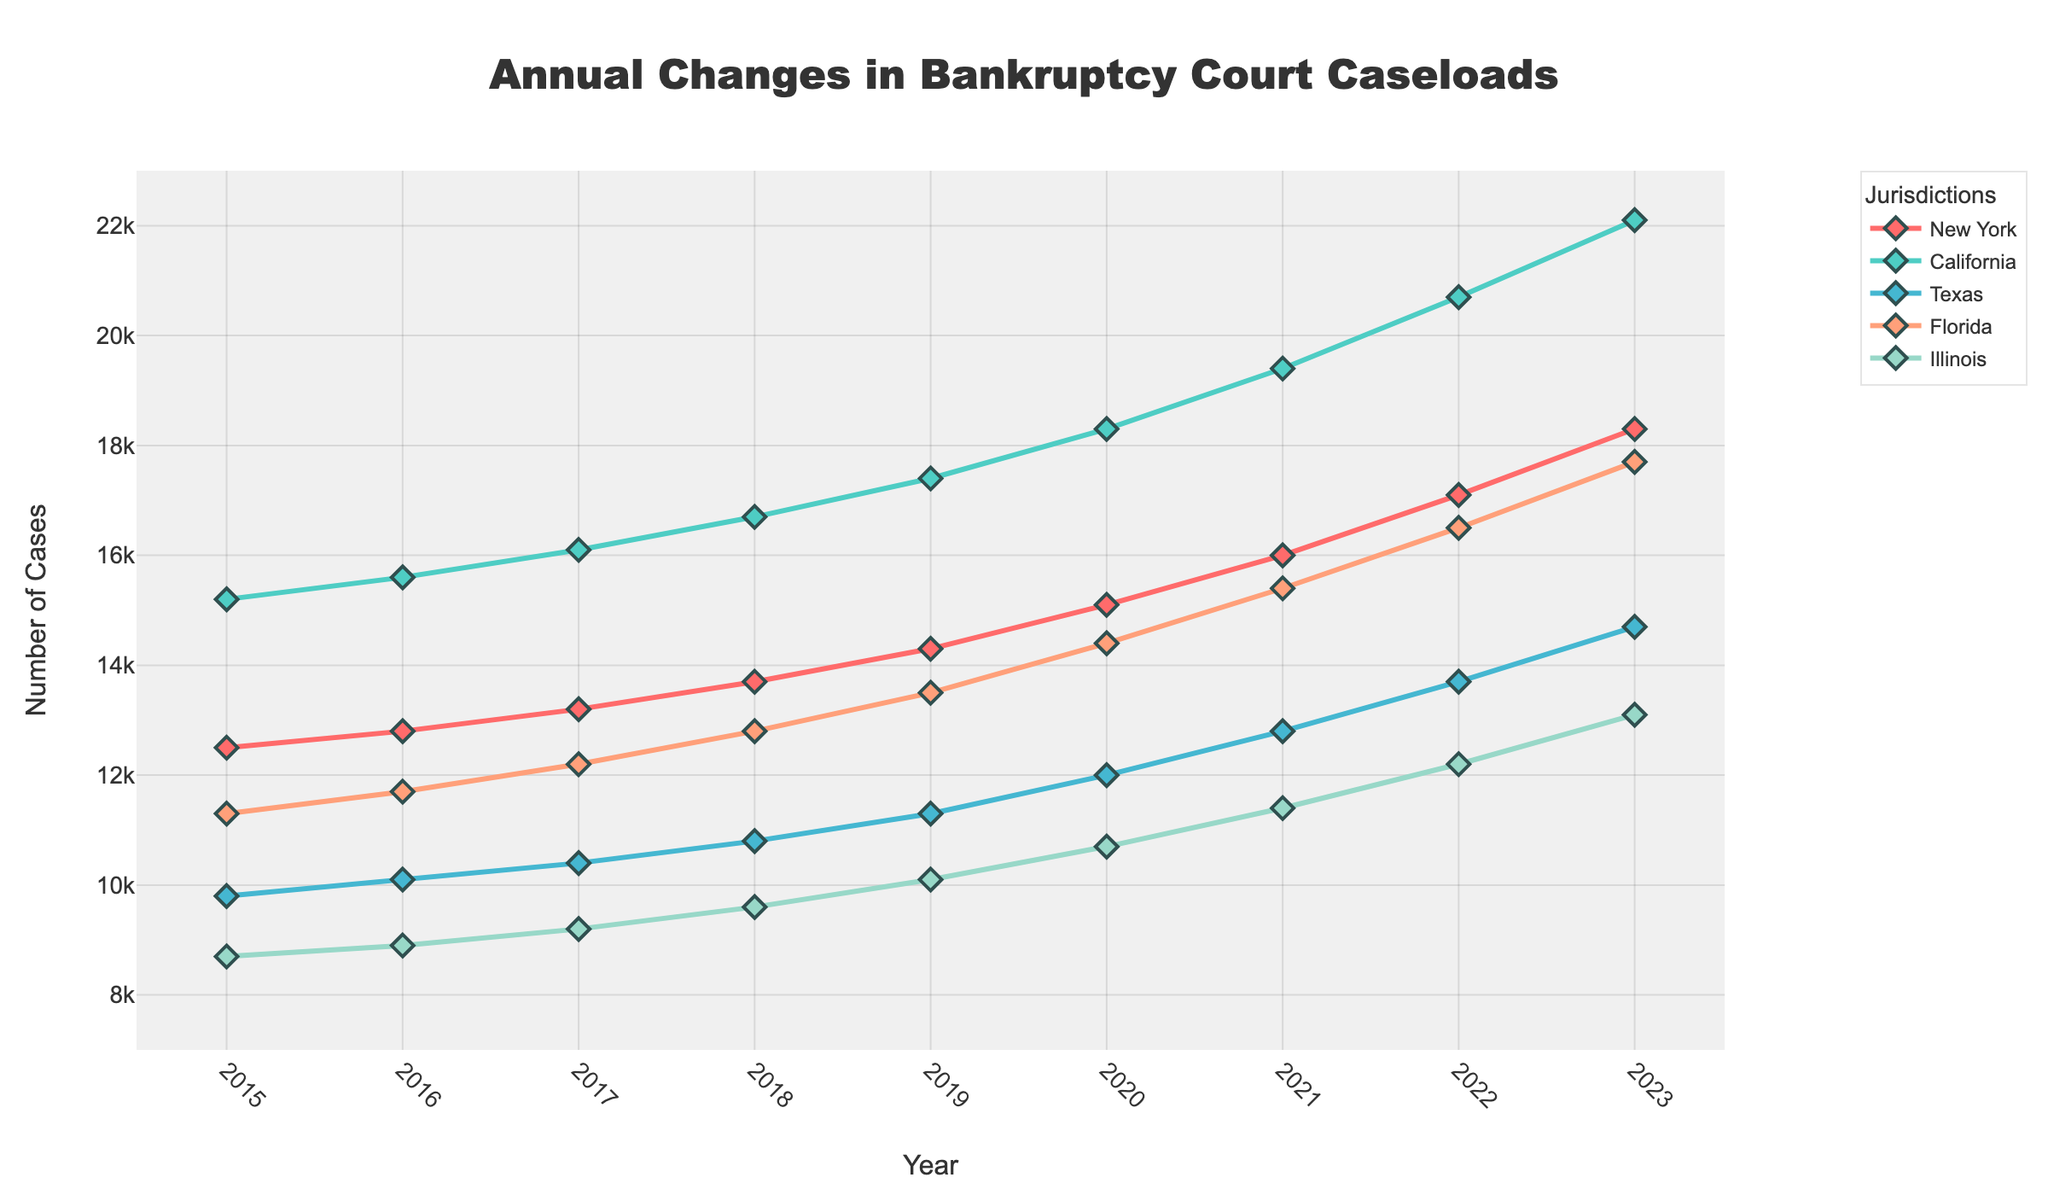How many cases did California have in 2018 compared to Florida in 2020? California had 16700 cases in 2018, while Florida had 14400 cases in 2020. This can be observed by examining the respective data points in the figure.
Answer: California had 2300 more cases than Florida What is the percentage increase in caseloads for Texas from 2017 to 2023? Texas had 10400 cases in 2017 and 14700 cases in 2023. The increase is 14700 - 10400 = 4300 cases. The percentage increase is (4300 / 10400) * 100 ≈ 41.35%.
Answer: Approximately 41.35% Which jurisdiction had the fastest growth rate in caseloads from 2015 to 2023? To determine the fastest growth rate, we calculate the difference in caseloads for each jurisdiction between 2015 and 2023, and then find the highest percentage increase. New York: (18300-12500)/12500*100 ≈ 46.4%, California: (22100-15200)/15200*100 ≈ 45.4%, Texas: (14700-9800)/9800*100 ≈ 50%, Florida: (17700-11300)/11300*100 ≈ 56.6%, Illinois: (13100-8700)/8700*100 ≈ 50.6%. Florida had the highest growth rate.
Answer: Florida What is the average number of cases per year for Illinois from 2015 to 2023? To find the average, sum the number of cases for Illinois from 2015 to 2023 and divide by the number of years (9). The sum is 8700 + 8900 + 9200 + 9600 + 10100 + 10700 + 11400 + 12200 + 13100 = 83900. The average is 83900 / 9 ≈ 9322.22.
Answer: Approximately 9322.22 In which year did New York surpass 15000 cases? By looking at the plotted line for New York, we notice that it surpasses 15000 cases in 2020, reaching 15100 cases.
Answer: 2020 Which year observed the highest caseload in any of the jurisdictions and where was it? The highest caseload observed in the figure is for California in 2023 with 22100 cases.
Answer: 2023 in California Compare the increase in caseloads from 2019 to 2023 for New York and Illinois. Which grew more and by how much? New York's caseload increased from 14300 to 18300, an increase of 4000 cases. Illinois' caseload increased from 10100 to 13100, an increase of 3000 cases. New York grew by 1000 more cases than Illinois.
Answer: New York grew by 1000 more cases What was the total number of cases across all jurisdictions in 2021? Sum the number of cases for each jurisdiction in 2021: New York (16000) + California (19400) + Texas (12800) + Florida (15400) + Illinois (11400) = 75000.
Answer: 75000 